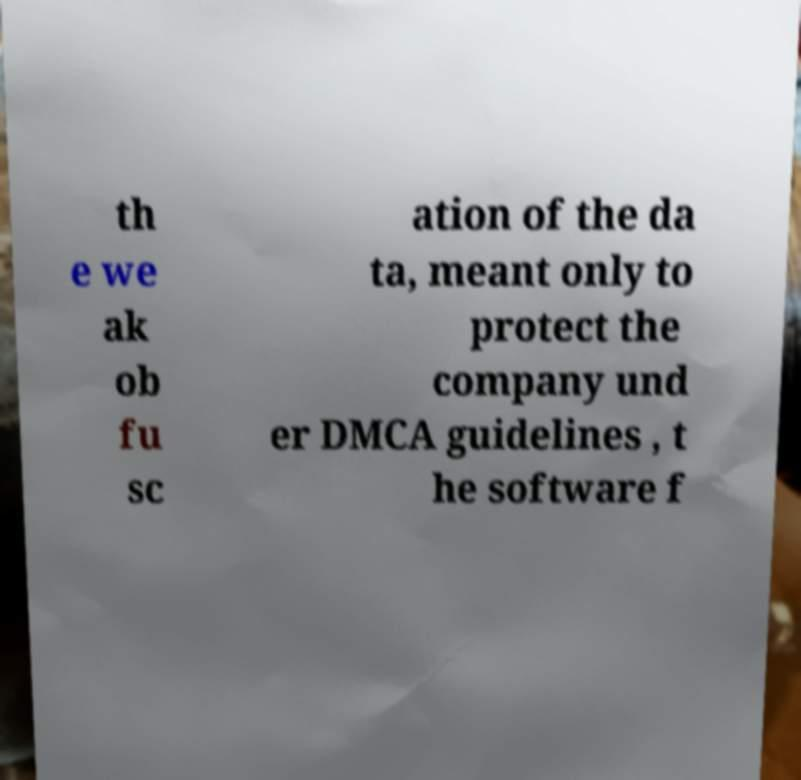For documentation purposes, I need the text within this image transcribed. Could you provide that? th e we ak ob fu sc ation of the da ta, meant only to protect the company und er DMCA guidelines , t he software f 